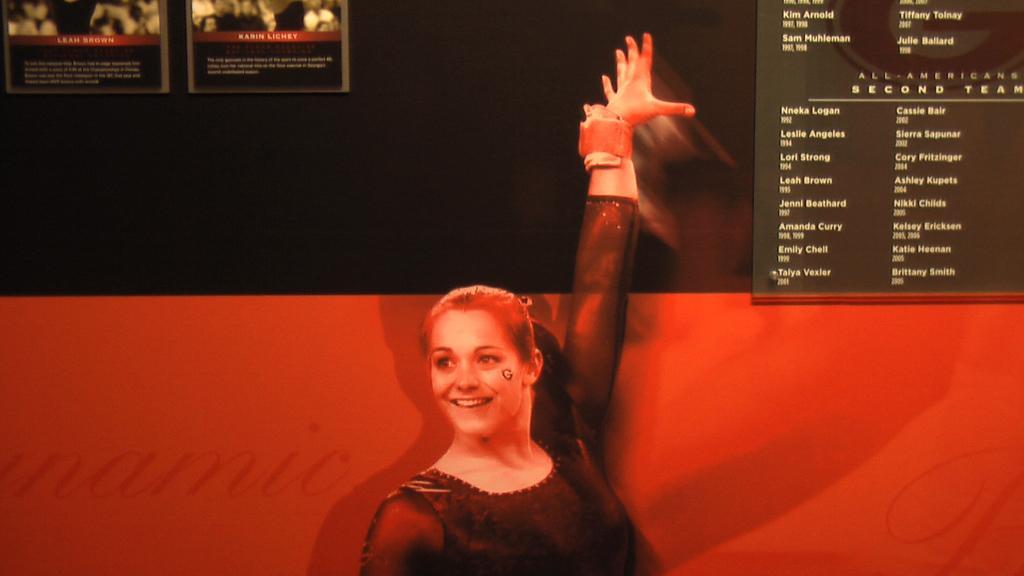How would you summarize this image in a sentence or two? In the picture I can see a woman wearing the black color top and there is a smile on her face. I can see two boards on the wall on the top left side. I can see a board with text on it on the top right side. 